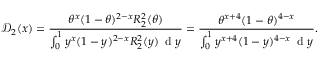Convert formula to latex. <formula><loc_0><loc_0><loc_500><loc_500>\mathcal { D } _ { 2 } ( x ) = \frac { \theta ^ { x } ( 1 - \theta ) ^ { 2 - x } R _ { 2 } ^ { 2 } ( \theta ) } { \int _ { 0 } ^ { 1 } y ^ { x } ( 1 - y ) ^ { 2 - x } R _ { 2 } ^ { 2 } ( y ) \, d y } = \frac { \theta ^ { x + 4 } ( 1 - \theta ) ^ { 4 - x } } { \int _ { 0 } ^ { 1 } y ^ { x + 4 } ( 1 - y ) ^ { 4 - x } \, d y } .</formula> 